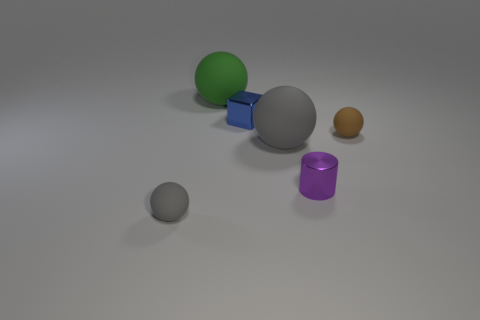Subtract 1 spheres. How many spheres are left? 3 Add 4 gray objects. How many objects exist? 10 Subtract all spheres. How many objects are left? 2 Add 3 balls. How many balls are left? 7 Add 6 green things. How many green things exist? 7 Subtract 0 blue spheres. How many objects are left? 6 Subtract all large red rubber cylinders. Subtract all blue shiny things. How many objects are left? 5 